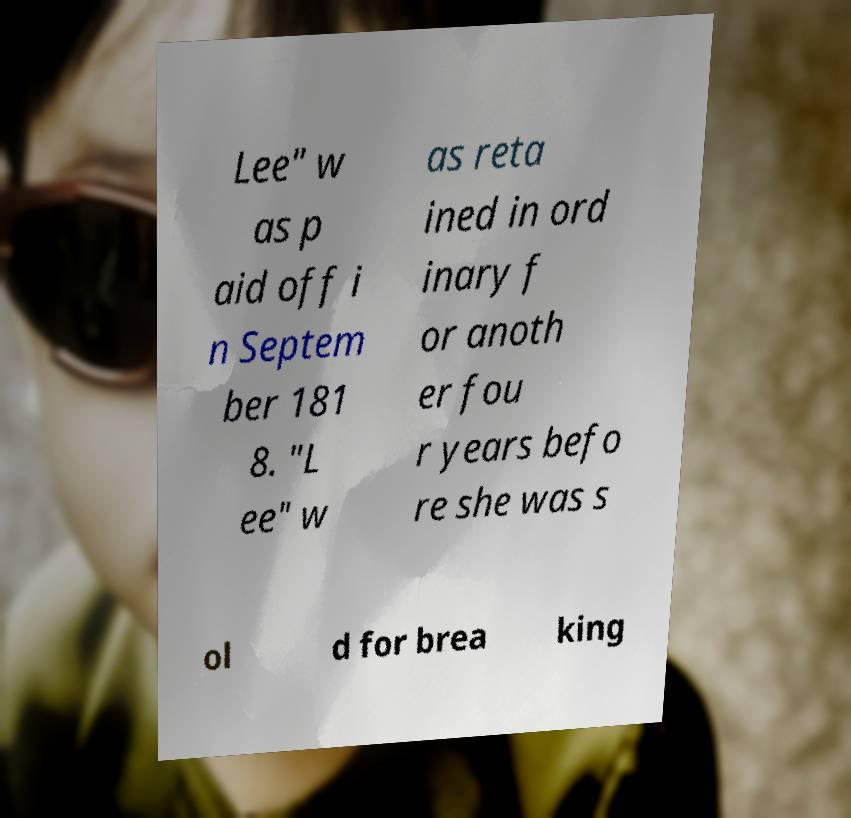For documentation purposes, I need the text within this image transcribed. Could you provide that? Lee" w as p aid off i n Septem ber 181 8. "L ee" w as reta ined in ord inary f or anoth er fou r years befo re she was s ol d for brea king 